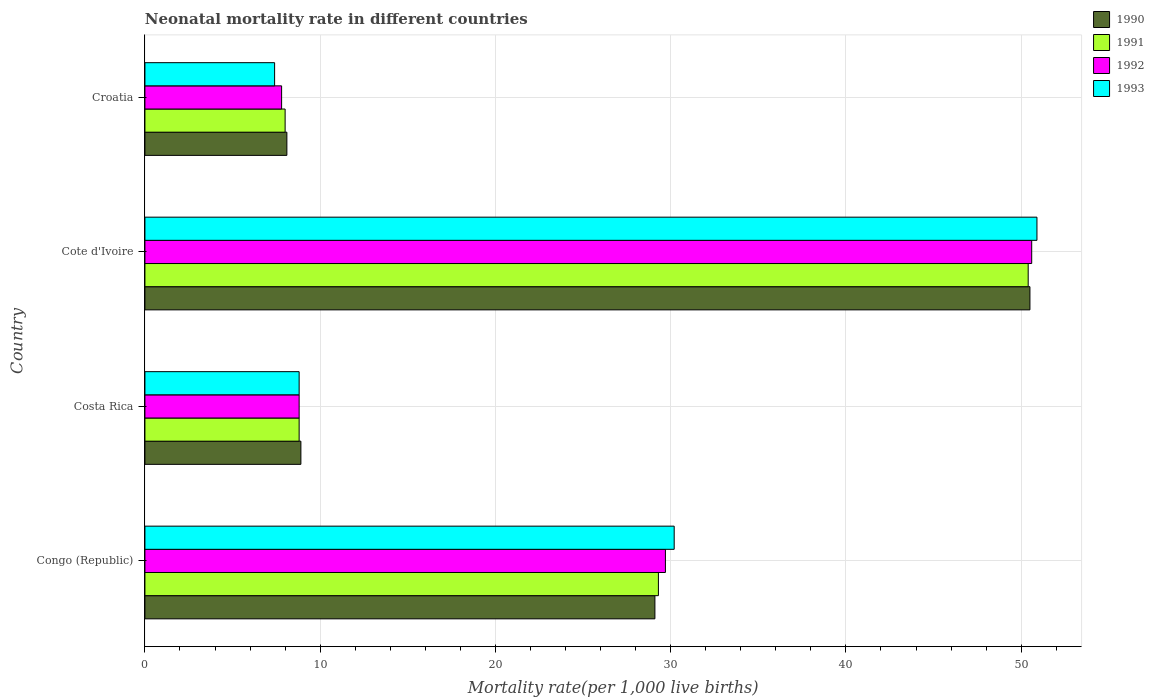Are the number of bars on each tick of the Y-axis equal?
Give a very brief answer. Yes. How many bars are there on the 3rd tick from the top?
Provide a succinct answer. 4. How many bars are there on the 1st tick from the bottom?
Offer a terse response. 4. What is the label of the 1st group of bars from the top?
Provide a succinct answer. Croatia. What is the neonatal mortality rate in 1990 in Cote d'Ivoire?
Keep it short and to the point. 50.5. Across all countries, what is the maximum neonatal mortality rate in 1993?
Your response must be concise. 50.9. Across all countries, what is the minimum neonatal mortality rate in 1991?
Your response must be concise. 8. In which country was the neonatal mortality rate in 1991 maximum?
Offer a terse response. Cote d'Ivoire. In which country was the neonatal mortality rate in 1991 minimum?
Keep it short and to the point. Croatia. What is the total neonatal mortality rate in 1992 in the graph?
Ensure brevity in your answer.  96.9. What is the difference between the neonatal mortality rate in 1993 in Congo (Republic) and that in Cote d'Ivoire?
Keep it short and to the point. -20.7. What is the difference between the neonatal mortality rate in 1992 in Croatia and the neonatal mortality rate in 1991 in Congo (Republic)?
Keep it short and to the point. -21.5. What is the average neonatal mortality rate in 1992 per country?
Make the answer very short. 24.22. What is the difference between the neonatal mortality rate in 1991 and neonatal mortality rate in 1992 in Cote d'Ivoire?
Your response must be concise. -0.2. What is the ratio of the neonatal mortality rate in 1991 in Costa Rica to that in Croatia?
Offer a very short reply. 1.1. What is the difference between the highest and the second highest neonatal mortality rate in 1993?
Offer a terse response. 20.7. What is the difference between the highest and the lowest neonatal mortality rate in 1993?
Offer a very short reply. 43.5. In how many countries, is the neonatal mortality rate in 1992 greater than the average neonatal mortality rate in 1992 taken over all countries?
Provide a succinct answer. 2. Is it the case that in every country, the sum of the neonatal mortality rate in 1992 and neonatal mortality rate in 1991 is greater than the sum of neonatal mortality rate in 1990 and neonatal mortality rate in 1993?
Provide a succinct answer. No. What does the 3rd bar from the top in Croatia represents?
Give a very brief answer. 1991. What does the 4th bar from the bottom in Costa Rica represents?
Give a very brief answer. 1993. Is it the case that in every country, the sum of the neonatal mortality rate in 1992 and neonatal mortality rate in 1991 is greater than the neonatal mortality rate in 1990?
Keep it short and to the point. Yes. How many countries are there in the graph?
Offer a terse response. 4. How many legend labels are there?
Offer a very short reply. 4. What is the title of the graph?
Provide a succinct answer. Neonatal mortality rate in different countries. What is the label or title of the X-axis?
Your answer should be compact. Mortality rate(per 1,0 live births). What is the Mortality rate(per 1,000 live births) in 1990 in Congo (Republic)?
Provide a short and direct response. 29.1. What is the Mortality rate(per 1,000 live births) in 1991 in Congo (Republic)?
Your answer should be very brief. 29.3. What is the Mortality rate(per 1,000 live births) of 1992 in Congo (Republic)?
Make the answer very short. 29.7. What is the Mortality rate(per 1,000 live births) of 1993 in Congo (Republic)?
Ensure brevity in your answer.  30.2. What is the Mortality rate(per 1,000 live births) in 1990 in Costa Rica?
Ensure brevity in your answer.  8.9. What is the Mortality rate(per 1,000 live births) of 1993 in Costa Rica?
Provide a short and direct response. 8.8. What is the Mortality rate(per 1,000 live births) in 1990 in Cote d'Ivoire?
Offer a very short reply. 50.5. What is the Mortality rate(per 1,000 live births) in 1991 in Cote d'Ivoire?
Your response must be concise. 50.4. What is the Mortality rate(per 1,000 live births) in 1992 in Cote d'Ivoire?
Your answer should be very brief. 50.6. What is the Mortality rate(per 1,000 live births) in 1993 in Cote d'Ivoire?
Ensure brevity in your answer.  50.9. What is the Mortality rate(per 1,000 live births) in 1992 in Croatia?
Your response must be concise. 7.8. Across all countries, what is the maximum Mortality rate(per 1,000 live births) in 1990?
Give a very brief answer. 50.5. Across all countries, what is the maximum Mortality rate(per 1,000 live births) in 1991?
Your answer should be very brief. 50.4. Across all countries, what is the maximum Mortality rate(per 1,000 live births) of 1992?
Provide a short and direct response. 50.6. Across all countries, what is the maximum Mortality rate(per 1,000 live births) of 1993?
Provide a succinct answer. 50.9. Across all countries, what is the minimum Mortality rate(per 1,000 live births) in 1990?
Ensure brevity in your answer.  8.1. What is the total Mortality rate(per 1,000 live births) of 1990 in the graph?
Keep it short and to the point. 96.6. What is the total Mortality rate(per 1,000 live births) in 1991 in the graph?
Offer a very short reply. 96.5. What is the total Mortality rate(per 1,000 live births) of 1992 in the graph?
Ensure brevity in your answer.  96.9. What is the total Mortality rate(per 1,000 live births) in 1993 in the graph?
Offer a very short reply. 97.3. What is the difference between the Mortality rate(per 1,000 live births) in 1990 in Congo (Republic) and that in Costa Rica?
Make the answer very short. 20.2. What is the difference between the Mortality rate(per 1,000 live births) in 1992 in Congo (Republic) and that in Costa Rica?
Keep it short and to the point. 20.9. What is the difference between the Mortality rate(per 1,000 live births) in 1993 in Congo (Republic) and that in Costa Rica?
Make the answer very short. 21.4. What is the difference between the Mortality rate(per 1,000 live births) of 1990 in Congo (Republic) and that in Cote d'Ivoire?
Your answer should be compact. -21.4. What is the difference between the Mortality rate(per 1,000 live births) in 1991 in Congo (Republic) and that in Cote d'Ivoire?
Offer a very short reply. -21.1. What is the difference between the Mortality rate(per 1,000 live births) in 1992 in Congo (Republic) and that in Cote d'Ivoire?
Your answer should be very brief. -20.9. What is the difference between the Mortality rate(per 1,000 live births) in 1993 in Congo (Republic) and that in Cote d'Ivoire?
Make the answer very short. -20.7. What is the difference between the Mortality rate(per 1,000 live births) in 1990 in Congo (Republic) and that in Croatia?
Provide a succinct answer. 21. What is the difference between the Mortality rate(per 1,000 live births) of 1991 in Congo (Republic) and that in Croatia?
Ensure brevity in your answer.  21.3. What is the difference between the Mortality rate(per 1,000 live births) in 1992 in Congo (Republic) and that in Croatia?
Your answer should be compact. 21.9. What is the difference between the Mortality rate(per 1,000 live births) of 1993 in Congo (Republic) and that in Croatia?
Make the answer very short. 22.8. What is the difference between the Mortality rate(per 1,000 live births) in 1990 in Costa Rica and that in Cote d'Ivoire?
Make the answer very short. -41.6. What is the difference between the Mortality rate(per 1,000 live births) in 1991 in Costa Rica and that in Cote d'Ivoire?
Ensure brevity in your answer.  -41.6. What is the difference between the Mortality rate(per 1,000 live births) of 1992 in Costa Rica and that in Cote d'Ivoire?
Offer a terse response. -41.8. What is the difference between the Mortality rate(per 1,000 live births) in 1993 in Costa Rica and that in Cote d'Ivoire?
Your response must be concise. -42.1. What is the difference between the Mortality rate(per 1,000 live births) of 1990 in Costa Rica and that in Croatia?
Give a very brief answer. 0.8. What is the difference between the Mortality rate(per 1,000 live births) of 1991 in Costa Rica and that in Croatia?
Offer a terse response. 0.8. What is the difference between the Mortality rate(per 1,000 live births) of 1990 in Cote d'Ivoire and that in Croatia?
Offer a very short reply. 42.4. What is the difference between the Mortality rate(per 1,000 live births) of 1991 in Cote d'Ivoire and that in Croatia?
Provide a short and direct response. 42.4. What is the difference between the Mortality rate(per 1,000 live births) of 1992 in Cote d'Ivoire and that in Croatia?
Offer a very short reply. 42.8. What is the difference between the Mortality rate(per 1,000 live births) of 1993 in Cote d'Ivoire and that in Croatia?
Ensure brevity in your answer.  43.5. What is the difference between the Mortality rate(per 1,000 live births) in 1990 in Congo (Republic) and the Mortality rate(per 1,000 live births) in 1991 in Costa Rica?
Offer a very short reply. 20.3. What is the difference between the Mortality rate(per 1,000 live births) in 1990 in Congo (Republic) and the Mortality rate(per 1,000 live births) in 1992 in Costa Rica?
Offer a terse response. 20.3. What is the difference between the Mortality rate(per 1,000 live births) in 1990 in Congo (Republic) and the Mortality rate(per 1,000 live births) in 1993 in Costa Rica?
Give a very brief answer. 20.3. What is the difference between the Mortality rate(per 1,000 live births) of 1991 in Congo (Republic) and the Mortality rate(per 1,000 live births) of 1992 in Costa Rica?
Offer a very short reply. 20.5. What is the difference between the Mortality rate(per 1,000 live births) of 1991 in Congo (Republic) and the Mortality rate(per 1,000 live births) of 1993 in Costa Rica?
Give a very brief answer. 20.5. What is the difference between the Mortality rate(per 1,000 live births) of 1992 in Congo (Republic) and the Mortality rate(per 1,000 live births) of 1993 in Costa Rica?
Offer a terse response. 20.9. What is the difference between the Mortality rate(per 1,000 live births) in 1990 in Congo (Republic) and the Mortality rate(per 1,000 live births) in 1991 in Cote d'Ivoire?
Provide a short and direct response. -21.3. What is the difference between the Mortality rate(per 1,000 live births) in 1990 in Congo (Republic) and the Mortality rate(per 1,000 live births) in 1992 in Cote d'Ivoire?
Ensure brevity in your answer.  -21.5. What is the difference between the Mortality rate(per 1,000 live births) in 1990 in Congo (Republic) and the Mortality rate(per 1,000 live births) in 1993 in Cote d'Ivoire?
Offer a very short reply. -21.8. What is the difference between the Mortality rate(per 1,000 live births) in 1991 in Congo (Republic) and the Mortality rate(per 1,000 live births) in 1992 in Cote d'Ivoire?
Your answer should be compact. -21.3. What is the difference between the Mortality rate(per 1,000 live births) of 1991 in Congo (Republic) and the Mortality rate(per 1,000 live births) of 1993 in Cote d'Ivoire?
Ensure brevity in your answer.  -21.6. What is the difference between the Mortality rate(per 1,000 live births) in 1992 in Congo (Republic) and the Mortality rate(per 1,000 live births) in 1993 in Cote d'Ivoire?
Your answer should be very brief. -21.2. What is the difference between the Mortality rate(per 1,000 live births) of 1990 in Congo (Republic) and the Mortality rate(per 1,000 live births) of 1991 in Croatia?
Keep it short and to the point. 21.1. What is the difference between the Mortality rate(per 1,000 live births) in 1990 in Congo (Republic) and the Mortality rate(per 1,000 live births) in 1992 in Croatia?
Provide a short and direct response. 21.3. What is the difference between the Mortality rate(per 1,000 live births) of 1990 in Congo (Republic) and the Mortality rate(per 1,000 live births) of 1993 in Croatia?
Give a very brief answer. 21.7. What is the difference between the Mortality rate(per 1,000 live births) in 1991 in Congo (Republic) and the Mortality rate(per 1,000 live births) in 1992 in Croatia?
Keep it short and to the point. 21.5. What is the difference between the Mortality rate(per 1,000 live births) in 1991 in Congo (Republic) and the Mortality rate(per 1,000 live births) in 1993 in Croatia?
Your answer should be very brief. 21.9. What is the difference between the Mortality rate(per 1,000 live births) of 1992 in Congo (Republic) and the Mortality rate(per 1,000 live births) of 1993 in Croatia?
Offer a terse response. 22.3. What is the difference between the Mortality rate(per 1,000 live births) of 1990 in Costa Rica and the Mortality rate(per 1,000 live births) of 1991 in Cote d'Ivoire?
Your response must be concise. -41.5. What is the difference between the Mortality rate(per 1,000 live births) of 1990 in Costa Rica and the Mortality rate(per 1,000 live births) of 1992 in Cote d'Ivoire?
Make the answer very short. -41.7. What is the difference between the Mortality rate(per 1,000 live births) of 1990 in Costa Rica and the Mortality rate(per 1,000 live births) of 1993 in Cote d'Ivoire?
Ensure brevity in your answer.  -42. What is the difference between the Mortality rate(per 1,000 live births) of 1991 in Costa Rica and the Mortality rate(per 1,000 live births) of 1992 in Cote d'Ivoire?
Your answer should be compact. -41.8. What is the difference between the Mortality rate(per 1,000 live births) in 1991 in Costa Rica and the Mortality rate(per 1,000 live births) in 1993 in Cote d'Ivoire?
Offer a very short reply. -42.1. What is the difference between the Mortality rate(per 1,000 live births) in 1992 in Costa Rica and the Mortality rate(per 1,000 live births) in 1993 in Cote d'Ivoire?
Keep it short and to the point. -42.1. What is the difference between the Mortality rate(per 1,000 live births) of 1990 in Costa Rica and the Mortality rate(per 1,000 live births) of 1991 in Croatia?
Make the answer very short. 0.9. What is the difference between the Mortality rate(per 1,000 live births) of 1990 in Costa Rica and the Mortality rate(per 1,000 live births) of 1992 in Croatia?
Ensure brevity in your answer.  1.1. What is the difference between the Mortality rate(per 1,000 live births) in 1992 in Costa Rica and the Mortality rate(per 1,000 live births) in 1993 in Croatia?
Your response must be concise. 1.4. What is the difference between the Mortality rate(per 1,000 live births) in 1990 in Cote d'Ivoire and the Mortality rate(per 1,000 live births) in 1991 in Croatia?
Provide a short and direct response. 42.5. What is the difference between the Mortality rate(per 1,000 live births) in 1990 in Cote d'Ivoire and the Mortality rate(per 1,000 live births) in 1992 in Croatia?
Offer a very short reply. 42.7. What is the difference between the Mortality rate(per 1,000 live births) of 1990 in Cote d'Ivoire and the Mortality rate(per 1,000 live births) of 1993 in Croatia?
Ensure brevity in your answer.  43.1. What is the difference between the Mortality rate(per 1,000 live births) of 1991 in Cote d'Ivoire and the Mortality rate(per 1,000 live births) of 1992 in Croatia?
Make the answer very short. 42.6. What is the difference between the Mortality rate(per 1,000 live births) of 1992 in Cote d'Ivoire and the Mortality rate(per 1,000 live births) of 1993 in Croatia?
Keep it short and to the point. 43.2. What is the average Mortality rate(per 1,000 live births) in 1990 per country?
Provide a succinct answer. 24.15. What is the average Mortality rate(per 1,000 live births) of 1991 per country?
Give a very brief answer. 24.12. What is the average Mortality rate(per 1,000 live births) of 1992 per country?
Make the answer very short. 24.23. What is the average Mortality rate(per 1,000 live births) in 1993 per country?
Make the answer very short. 24.32. What is the difference between the Mortality rate(per 1,000 live births) of 1990 and Mortality rate(per 1,000 live births) of 1991 in Congo (Republic)?
Ensure brevity in your answer.  -0.2. What is the difference between the Mortality rate(per 1,000 live births) in 1990 and Mortality rate(per 1,000 live births) in 1993 in Congo (Republic)?
Keep it short and to the point. -1.1. What is the difference between the Mortality rate(per 1,000 live births) of 1991 and Mortality rate(per 1,000 live births) of 1992 in Congo (Republic)?
Your answer should be compact. -0.4. What is the difference between the Mortality rate(per 1,000 live births) in 1992 and Mortality rate(per 1,000 live births) in 1993 in Congo (Republic)?
Provide a succinct answer. -0.5. What is the difference between the Mortality rate(per 1,000 live births) in 1990 and Mortality rate(per 1,000 live births) in 1991 in Costa Rica?
Your response must be concise. 0.1. What is the difference between the Mortality rate(per 1,000 live births) of 1990 and Mortality rate(per 1,000 live births) of 1992 in Costa Rica?
Keep it short and to the point. 0.1. What is the difference between the Mortality rate(per 1,000 live births) in 1991 and Mortality rate(per 1,000 live births) in 1992 in Costa Rica?
Make the answer very short. 0. What is the difference between the Mortality rate(per 1,000 live births) of 1990 and Mortality rate(per 1,000 live births) of 1991 in Cote d'Ivoire?
Offer a terse response. 0.1. What is the difference between the Mortality rate(per 1,000 live births) in 1990 and Mortality rate(per 1,000 live births) in 1993 in Cote d'Ivoire?
Provide a short and direct response. -0.4. What is the difference between the Mortality rate(per 1,000 live births) in 1991 and Mortality rate(per 1,000 live births) in 1992 in Cote d'Ivoire?
Keep it short and to the point. -0.2. What is the difference between the Mortality rate(per 1,000 live births) of 1992 and Mortality rate(per 1,000 live births) of 1993 in Cote d'Ivoire?
Give a very brief answer. -0.3. What is the difference between the Mortality rate(per 1,000 live births) of 1990 and Mortality rate(per 1,000 live births) of 1992 in Croatia?
Make the answer very short. 0.3. What is the difference between the Mortality rate(per 1,000 live births) in 1990 and Mortality rate(per 1,000 live births) in 1993 in Croatia?
Your answer should be very brief. 0.7. What is the difference between the Mortality rate(per 1,000 live births) in 1991 and Mortality rate(per 1,000 live births) in 1993 in Croatia?
Provide a succinct answer. 0.6. What is the ratio of the Mortality rate(per 1,000 live births) of 1990 in Congo (Republic) to that in Costa Rica?
Ensure brevity in your answer.  3.27. What is the ratio of the Mortality rate(per 1,000 live births) of 1991 in Congo (Republic) to that in Costa Rica?
Your response must be concise. 3.33. What is the ratio of the Mortality rate(per 1,000 live births) of 1992 in Congo (Republic) to that in Costa Rica?
Your response must be concise. 3.38. What is the ratio of the Mortality rate(per 1,000 live births) of 1993 in Congo (Republic) to that in Costa Rica?
Offer a very short reply. 3.43. What is the ratio of the Mortality rate(per 1,000 live births) in 1990 in Congo (Republic) to that in Cote d'Ivoire?
Keep it short and to the point. 0.58. What is the ratio of the Mortality rate(per 1,000 live births) of 1991 in Congo (Republic) to that in Cote d'Ivoire?
Your answer should be compact. 0.58. What is the ratio of the Mortality rate(per 1,000 live births) of 1992 in Congo (Republic) to that in Cote d'Ivoire?
Give a very brief answer. 0.59. What is the ratio of the Mortality rate(per 1,000 live births) in 1993 in Congo (Republic) to that in Cote d'Ivoire?
Offer a terse response. 0.59. What is the ratio of the Mortality rate(per 1,000 live births) in 1990 in Congo (Republic) to that in Croatia?
Keep it short and to the point. 3.59. What is the ratio of the Mortality rate(per 1,000 live births) of 1991 in Congo (Republic) to that in Croatia?
Ensure brevity in your answer.  3.66. What is the ratio of the Mortality rate(per 1,000 live births) of 1992 in Congo (Republic) to that in Croatia?
Provide a short and direct response. 3.81. What is the ratio of the Mortality rate(per 1,000 live births) in 1993 in Congo (Republic) to that in Croatia?
Provide a short and direct response. 4.08. What is the ratio of the Mortality rate(per 1,000 live births) in 1990 in Costa Rica to that in Cote d'Ivoire?
Your answer should be very brief. 0.18. What is the ratio of the Mortality rate(per 1,000 live births) of 1991 in Costa Rica to that in Cote d'Ivoire?
Offer a terse response. 0.17. What is the ratio of the Mortality rate(per 1,000 live births) of 1992 in Costa Rica to that in Cote d'Ivoire?
Make the answer very short. 0.17. What is the ratio of the Mortality rate(per 1,000 live births) in 1993 in Costa Rica to that in Cote d'Ivoire?
Provide a short and direct response. 0.17. What is the ratio of the Mortality rate(per 1,000 live births) of 1990 in Costa Rica to that in Croatia?
Your response must be concise. 1.1. What is the ratio of the Mortality rate(per 1,000 live births) of 1992 in Costa Rica to that in Croatia?
Keep it short and to the point. 1.13. What is the ratio of the Mortality rate(per 1,000 live births) in 1993 in Costa Rica to that in Croatia?
Keep it short and to the point. 1.19. What is the ratio of the Mortality rate(per 1,000 live births) in 1990 in Cote d'Ivoire to that in Croatia?
Your response must be concise. 6.23. What is the ratio of the Mortality rate(per 1,000 live births) of 1991 in Cote d'Ivoire to that in Croatia?
Your response must be concise. 6.3. What is the ratio of the Mortality rate(per 1,000 live births) in 1992 in Cote d'Ivoire to that in Croatia?
Make the answer very short. 6.49. What is the ratio of the Mortality rate(per 1,000 live births) of 1993 in Cote d'Ivoire to that in Croatia?
Your answer should be very brief. 6.88. What is the difference between the highest and the second highest Mortality rate(per 1,000 live births) in 1990?
Give a very brief answer. 21.4. What is the difference between the highest and the second highest Mortality rate(per 1,000 live births) of 1991?
Your answer should be very brief. 21.1. What is the difference between the highest and the second highest Mortality rate(per 1,000 live births) of 1992?
Your response must be concise. 20.9. What is the difference between the highest and the second highest Mortality rate(per 1,000 live births) in 1993?
Provide a short and direct response. 20.7. What is the difference between the highest and the lowest Mortality rate(per 1,000 live births) in 1990?
Your answer should be compact. 42.4. What is the difference between the highest and the lowest Mortality rate(per 1,000 live births) of 1991?
Your answer should be very brief. 42.4. What is the difference between the highest and the lowest Mortality rate(per 1,000 live births) in 1992?
Provide a short and direct response. 42.8. What is the difference between the highest and the lowest Mortality rate(per 1,000 live births) of 1993?
Provide a succinct answer. 43.5. 